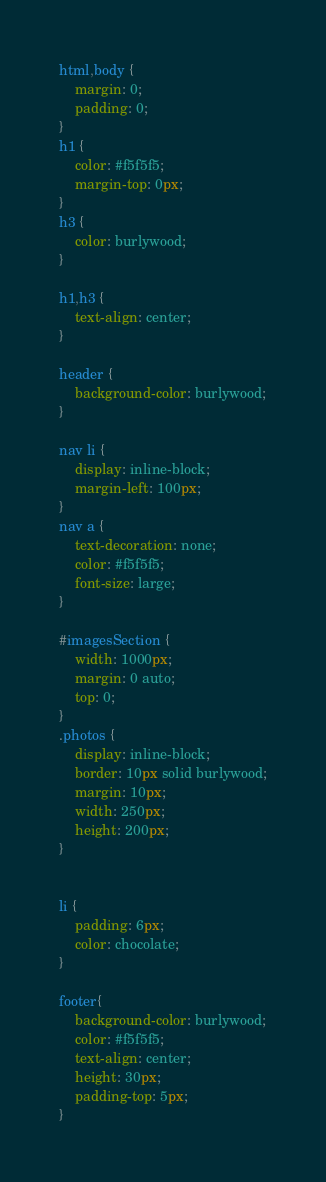<code> <loc_0><loc_0><loc_500><loc_500><_CSS_>html,body {
    margin: 0;
    padding: 0;
}
h1 {
    color: #f5f5f5;
    margin-top: 0px;
}
h3 {
    color: burlywood;
}

h1,h3 {
    text-align: center;
}

header {
    background-color: burlywood;
}

nav li {
    display: inline-block;
    margin-left: 100px;
}
nav a {
    text-decoration: none;
    color: #f5f5f5;
    font-size: large;
}

#imagesSection {
    width: 1000px;
    margin: 0 auto;
    top: 0;
}
.photos {
    display: inline-block;
    border: 10px solid burlywood;
    margin: 10px;
    width: 250px;
    height: 200px;
}


li {
    padding: 6px;
    color: chocolate;
}

footer{
    background-color: burlywood;
    color: #f5f5f5;
    text-align: center;
    height: 30px;
    padding-top: 5px;
}</code> 